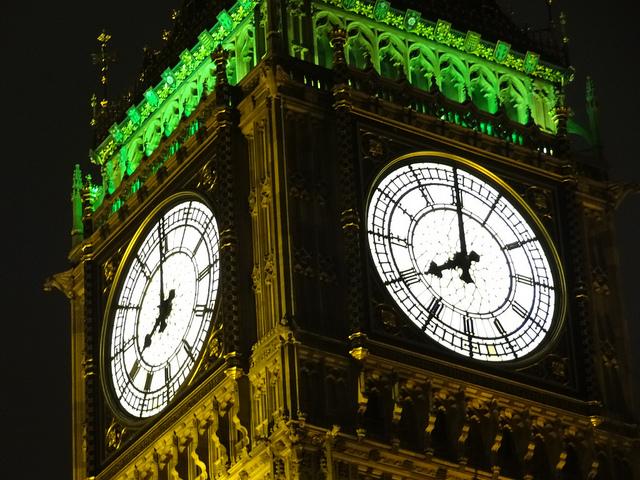What is coloring the upper design green?
Be succinct. Lights. Are there numbers on the clock?
Concise answer only. No. What time does the clock read?
Keep it brief. 8:00. 